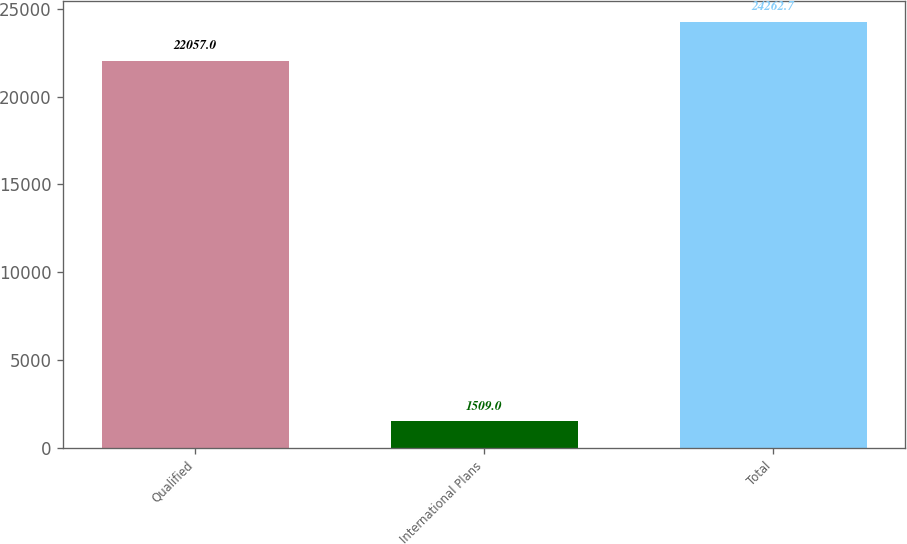Convert chart. <chart><loc_0><loc_0><loc_500><loc_500><bar_chart><fcel>Qualified<fcel>International Plans<fcel>Total<nl><fcel>22057<fcel>1509<fcel>24262.7<nl></chart> 